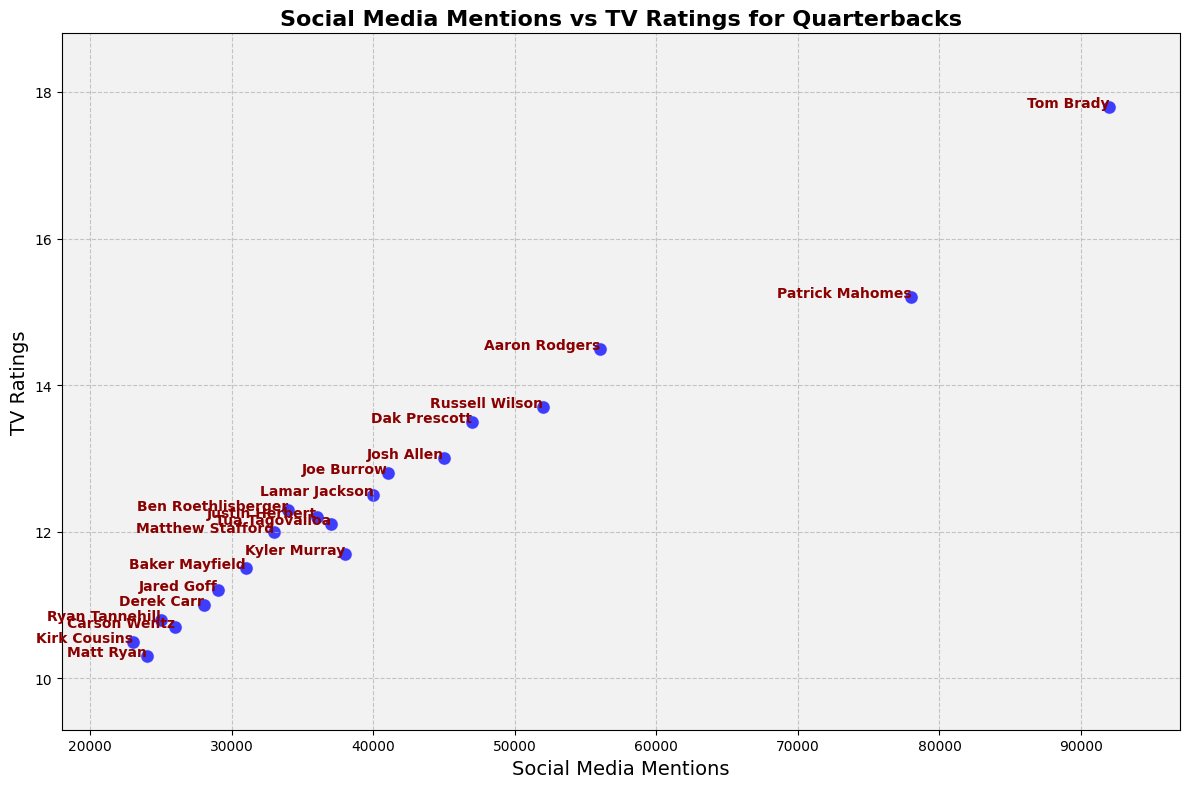What's the quarterback with the highest social media mentions? Look for the quarterback point that is farthest to the right on the x-axis. Tom Brady has the highest social media mentions at 92,000.
Answer: Tom Brady What is the average TV rating of the quarterbacks with more than 50,000 social media mentions? The quarterbacks with more than 50,000 social media mentions are Aaron Rodgers (14.5), Patrick Mahomes (15.2), Tom Brady (17.8), and Russell Wilson (13.7). The average is calculated as (14.5 + 15.2 + 17.8 + 13.7) / 4 = 15.3.
Answer: 15.3 Which quarterback has the lowest TV rating, and what is the rating? Identify the quarterback with the point lowest on the y-axis. Matt Ryan has the lowest TV rating, which is 10.3.
Answer: Matt Ryan, 10.3 Are there any quarterbacks with exactly 12.0 TV ratings? If so, who are they? Look for the points with a y-value of 12.0. Matthew Stafford has a TV rating of exactly 12.0.
Answer: Matthew Stafford Which quarterback with less than 30,000 social media mentions has the highest TV rating? Find the quarterbacks with social media mentions less than 30,000 and compare their TV ratings. Kirk Cousins has the highest TV rating, which is 10.5.
Answer: Kirk Cousins Who has more social media mentions, Dak Prescott or Josh Allen? Compare the points for Dak Prescott and Josh Allen based on their x-values. Dak Prescott has 47,000 social media mentions, while Josh Allen has 45,000.
Answer: Dak Prescott What's the range of TV ratings for the quarterbacks? Identify the highest and lowest y-values in the chart. The highest TV rating is 17.8 (Tom Brady), and the lowest is 10.3 (Matt Ryan). The range is 17.8 - 10.3 = 7.5.
Answer: 7.5 What is the sum of social media mentions for quarterbacks with TV ratings above 15? Identify the quarterbacks with TV ratings above 15: Patrick Mahomes (78,000) and Tom Brady (92,000). The sum is 78,000 + 92,000 = 170,000.
Answer: 170,000 What's the difference in social media mentions between the quarterback with the highest and the lowest TV ratings? The quarterback with the highest TV rating is Tom Brady (92,000 social media mentions), and the lowest is Matt Ryan (24,000 social media mentions). The difference is 92,000 - 24,000 = 68,000.
Answer: 68,000 